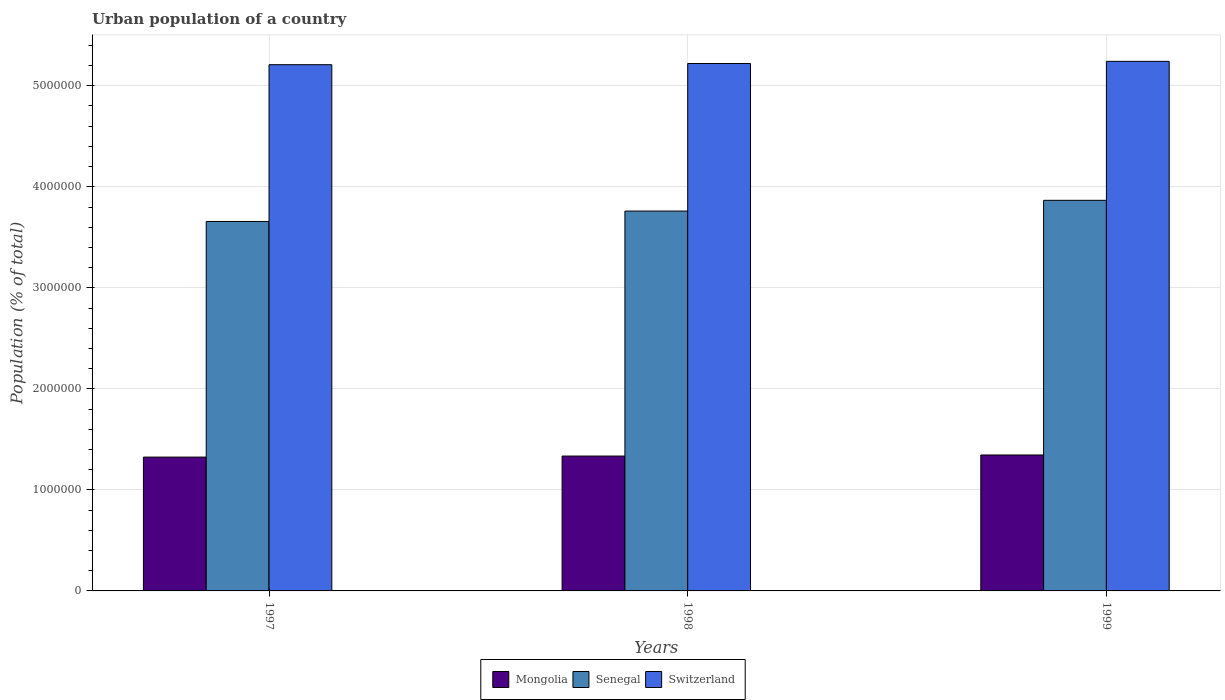How many different coloured bars are there?
Keep it short and to the point. 3. How many groups of bars are there?
Provide a succinct answer. 3. Are the number of bars on each tick of the X-axis equal?
Provide a succinct answer. Yes. How many bars are there on the 1st tick from the left?
Your answer should be very brief. 3. What is the label of the 2nd group of bars from the left?
Give a very brief answer. 1998. In how many cases, is the number of bars for a given year not equal to the number of legend labels?
Provide a short and direct response. 0. What is the urban population in Switzerland in 1997?
Give a very brief answer. 5.21e+06. Across all years, what is the maximum urban population in Mongolia?
Offer a terse response. 1.35e+06. Across all years, what is the minimum urban population in Mongolia?
Offer a terse response. 1.32e+06. What is the total urban population in Senegal in the graph?
Provide a short and direct response. 1.13e+07. What is the difference between the urban population in Senegal in 1997 and that in 1999?
Offer a terse response. -2.09e+05. What is the difference between the urban population in Senegal in 1997 and the urban population in Switzerland in 1999?
Offer a very short reply. -1.58e+06. What is the average urban population in Mongolia per year?
Your response must be concise. 1.34e+06. In the year 1999, what is the difference between the urban population in Senegal and urban population in Mongolia?
Keep it short and to the point. 2.52e+06. What is the ratio of the urban population in Senegal in 1997 to that in 1998?
Keep it short and to the point. 0.97. What is the difference between the highest and the second highest urban population in Mongolia?
Provide a short and direct response. 1.06e+04. What is the difference between the highest and the lowest urban population in Senegal?
Your answer should be compact. 2.09e+05. Is the sum of the urban population in Switzerland in 1998 and 1999 greater than the maximum urban population in Mongolia across all years?
Your answer should be very brief. Yes. What does the 3rd bar from the left in 1999 represents?
Keep it short and to the point. Switzerland. What does the 2nd bar from the right in 1997 represents?
Your response must be concise. Senegal. Is it the case that in every year, the sum of the urban population in Mongolia and urban population in Senegal is greater than the urban population in Switzerland?
Ensure brevity in your answer.  No. Are all the bars in the graph horizontal?
Ensure brevity in your answer.  No. How many years are there in the graph?
Give a very brief answer. 3. What is the difference between two consecutive major ticks on the Y-axis?
Keep it short and to the point. 1.00e+06. Does the graph contain any zero values?
Your answer should be compact. No. Does the graph contain grids?
Your answer should be very brief. Yes. How many legend labels are there?
Your answer should be compact. 3. How are the legend labels stacked?
Make the answer very short. Horizontal. What is the title of the graph?
Ensure brevity in your answer.  Urban population of a country. Does "Greece" appear as one of the legend labels in the graph?
Ensure brevity in your answer.  No. What is the label or title of the X-axis?
Offer a very short reply. Years. What is the label or title of the Y-axis?
Make the answer very short. Population (% of total). What is the Population (% of total) of Mongolia in 1997?
Your answer should be compact. 1.32e+06. What is the Population (% of total) of Senegal in 1997?
Your response must be concise. 3.66e+06. What is the Population (% of total) in Switzerland in 1997?
Offer a very short reply. 5.21e+06. What is the Population (% of total) of Mongolia in 1998?
Provide a short and direct response. 1.33e+06. What is the Population (% of total) of Senegal in 1998?
Provide a short and direct response. 3.76e+06. What is the Population (% of total) of Switzerland in 1998?
Provide a succinct answer. 5.22e+06. What is the Population (% of total) of Mongolia in 1999?
Your answer should be very brief. 1.35e+06. What is the Population (% of total) of Senegal in 1999?
Offer a terse response. 3.87e+06. What is the Population (% of total) in Switzerland in 1999?
Keep it short and to the point. 5.24e+06. Across all years, what is the maximum Population (% of total) in Mongolia?
Keep it short and to the point. 1.35e+06. Across all years, what is the maximum Population (% of total) of Senegal?
Make the answer very short. 3.87e+06. Across all years, what is the maximum Population (% of total) of Switzerland?
Your answer should be compact. 5.24e+06. Across all years, what is the minimum Population (% of total) in Mongolia?
Make the answer very short. 1.32e+06. Across all years, what is the minimum Population (% of total) of Senegal?
Provide a succinct answer. 3.66e+06. Across all years, what is the minimum Population (% of total) of Switzerland?
Your response must be concise. 5.21e+06. What is the total Population (% of total) in Mongolia in the graph?
Offer a very short reply. 4.01e+06. What is the total Population (% of total) in Senegal in the graph?
Keep it short and to the point. 1.13e+07. What is the total Population (% of total) in Switzerland in the graph?
Provide a short and direct response. 1.57e+07. What is the difference between the Population (% of total) of Mongolia in 1997 and that in 1998?
Your answer should be very brief. -1.02e+04. What is the difference between the Population (% of total) in Senegal in 1997 and that in 1998?
Give a very brief answer. -1.03e+05. What is the difference between the Population (% of total) in Switzerland in 1997 and that in 1998?
Your answer should be very brief. -1.18e+04. What is the difference between the Population (% of total) in Mongolia in 1997 and that in 1999?
Keep it short and to the point. -2.08e+04. What is the difference between the Population (% of total) in Senegal in 1997 and that in 1999?
Provide a succinct answer. -2.09e+05. What is the difference between the Population (% of total) of Switzerland in 1997 and that in 1999?
Ensure brevity in your answer.  -3.31e+04. What is the difference between the Population (% of total) of Mongolia in 1998 and that in 1999?
Your answer should be compact. -1.06e+04. What is the difference between the Population (% of total) in Senegal in 1998 and that in 1999?
Make the answer very short. -1.06e+05. What is the difference between the Population (% of total) of Switzerland in 1998 and that in 1999?
Offer a very short reply. -2.13e+04. What is the difference between the Population (% of total) in Mongolia in 1997 and the Population (% of total) in Senegal in 1998?
Make the answer very short. -2.44e+06. What is the difference between the Population (% of total) in Mongolia in 1997 and the Population (% of total) in Switzerland in 1998?
Offer a very short reply. -3.90e+06. What is the difference between the Population (% of total) in Senegal in 1997 and the Population (% of total) in Switzerland in 1998?
Your response must be concise. -1.56e+06. What is the difference between the Population (% of total) in Mongolia in 1997 and the Population (% of total) in Senegal in 1999?
Provide a short and direct response. -2.54e+06. What is the difference between the Population (% of total) in Mongolia in 1997 and the Population (% of total) in Switzerland in 1999?
Ensure brevity in your answer.  -3.92e+06. What is the difference between the Population (% of total) in Senegal in 1997 and the Population (% of total) in Switzerland in 1999?
Give a very brief answer. -1.58e+06. What is the difference between the Population (% of total) of Mongolia in 1998 and the Population (% of total) of Senegal in 1999?
Offer a terse response. -2.53e+06. What is the difference between the Population (% of total) of Mongolia in 1998 and the Population (% of total) of Switzerland in 1999?
Offer a terse response. -3.91e+06. What is the difference between the Population (% of total) in Senegal in 1998 and the Population (% of total) in Switzerland in 1999?
Give a very brief answer. -1.48e+06. What is the average Population (% of total) in Mongolia per year?
Your answer should be very brief. 1.34e+06. What is the average Population (% of total) in Senegal per year?
Provide a short and direct response. 3.76e+06. What is the average Population (% of total) of Switzerland per year?
Your response must be concise. 5.22e+06. In the year 1997, what is the difference between the Population (% of total) in Mongolia and Population (% of total) in Senegal?
Offer a very short reply. -2.33e+06. In the year 1997, what is the difference between the Population (% of total) in Mongolia and Population (% of total) in Switzerland?
Keep it short and to the point. -3.88e+06. In the year 1997, what is the difference between the Population (% of total) of Senegal and Population (% of total) of Switzerland?
Offer a very short reply. -1.55e+06. In the year 1998, what is the difference between the Population (% of total) of Mongolia and Population (% of total) of Senegal?
Offer a very short reply. -2.43e+06. In the year 1998, what is the difference between the Population (% of total) in Mongolia and Population (% of total) in Switzerland?
Your answer should be compact. -3.89e+06. In the year 1998, what is the difference between the Population (% of total) of Senegal and Population (% of total) of Switzerland?
Keep it short and to the point. -1.46e+06. In the year 1999, what is the difference between the Population (% of total) in Mongolia and Population (% of total) in Senegal?
Make the answer very short. -2.52e+06. In the year 1999, what is the difference between the Population (% of total) of Mongolia and Population (% of total) of Switzerland?
Ensure brevity in your answer.  -3.90e+06. In the year 1999, what is the difference between the Population (% of total) in Senegal and Population (% of total) in Switzerland?
Provide a short and direct response. -1.38e+06. What is the ratio of the Population (% of total) in Mongolia in 1997 to that in 1998?
Provide a short and direct response. 0.99. What is the ratio of the Population (% of total) of Senegal in 1997 to that in 1998?
Provide a succinct answer. 0.97. What is the ratio of the Population (% of total) in Switzerland in 1997 to that in 1998?
Make the answer very short. 1. What is the ratio of the Population (% of total) in Mongolia in 1997 to that in 1999?
Provide a succinct answer. 0.98. What is the ratio of the Population (% of total) in Senegal in 1997 to that in 1999?
Ensure brevity in your answer.  0.95. What is the ratio of the Population (% of total) in Switzerland in 1997 to that in 1999?
Offer a terse response. 0.99. What is the ratio of the Population (% of total) of Mongolia in 1998 to that in 1999?
Your answer should be compact. 0.99. What is the ratio of the Population (% of total) of Senegal in 1998 to that in 1999?
Offer a very short reply. 0.97. What is the ratio of the Population (% of total) in Switzerland in 1998 to that in 1999?
Make the answer very short. 1. What is the difference between the highest and the second highest Population (% of total) in Mongolia?
Your response must be concise. 1.06e+04. What is the difference between the highest and the second highest Population (% of total) of Senegal?
Your answer should be compact. 1.06e+05. What is the difference between the highest and the second highest Population (% of total) in Switzerland?
Provide a short and direct response. 2.13e+04. What is the difference between the highest and the lowest Population (% of total) of Mongolia?
Your answer should be very brief. 2.08e+04. What is the difference between the highest and the lowest Population (% of total) of Senegal?
Your answer should be compact. 2.09e+05. What is the difference between the highest and the lowest Population (% of total) in Switzerland?
Your answer should be very brief. 3.31e+04. 